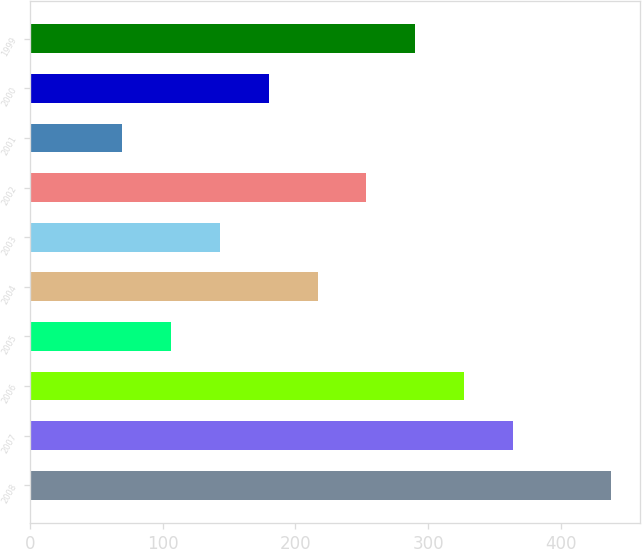Convert chart to OTSL. <chart><loc_0><loc_0><loc_500><loc_500><bar_chart><fcel>2008<fcel>2007<fcel>2006<fcel>2005<fcel>2004<fcel>2003<fcel>2002<fcel>2001<fcel>2000<fcel>1999<nl><fcel>438<fcel>364.2<fcel>327.3<fcel>105.9<fcel>216.6<fcel>142.8<fcel>253.5<fcel>69<fcel>179.7<fcel>290.4<nl></chart> 